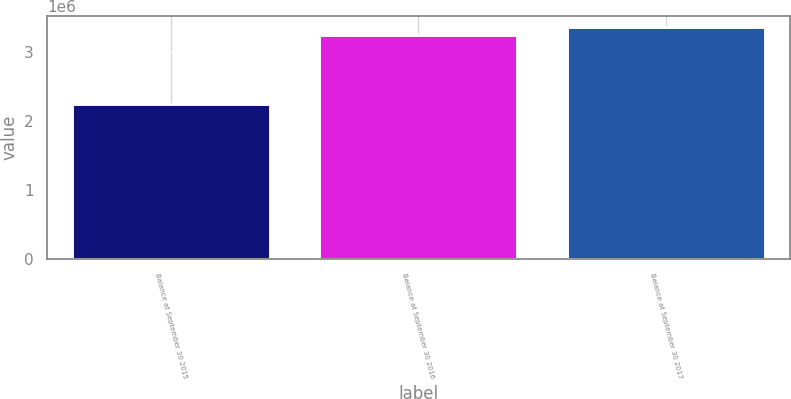<chart> <loc_0><loc_0><loc_500><loc_500><bar_chart><fcel>Balance at September 30 2015<fcel>Balance at September 30 2016<fcel>Balance at September 30 2017<nl><fcel>2.23844e+06<fcel>3.24749e+06<fcel>3.35443e+06<nl></chart> 